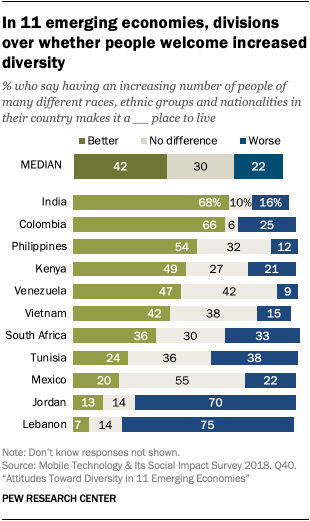Identify some key points in this picture. According to a survey conducted in India, 68% of the population believes that having a growing number of people from various races, ethnic groups, and nationalities in their country makes it a better place to live. In India, a higher number of people is perceived as making the country a worse place to live, with a value of 0.09. In Colombia, the same perception is held, but the value is lower at 0.03. 